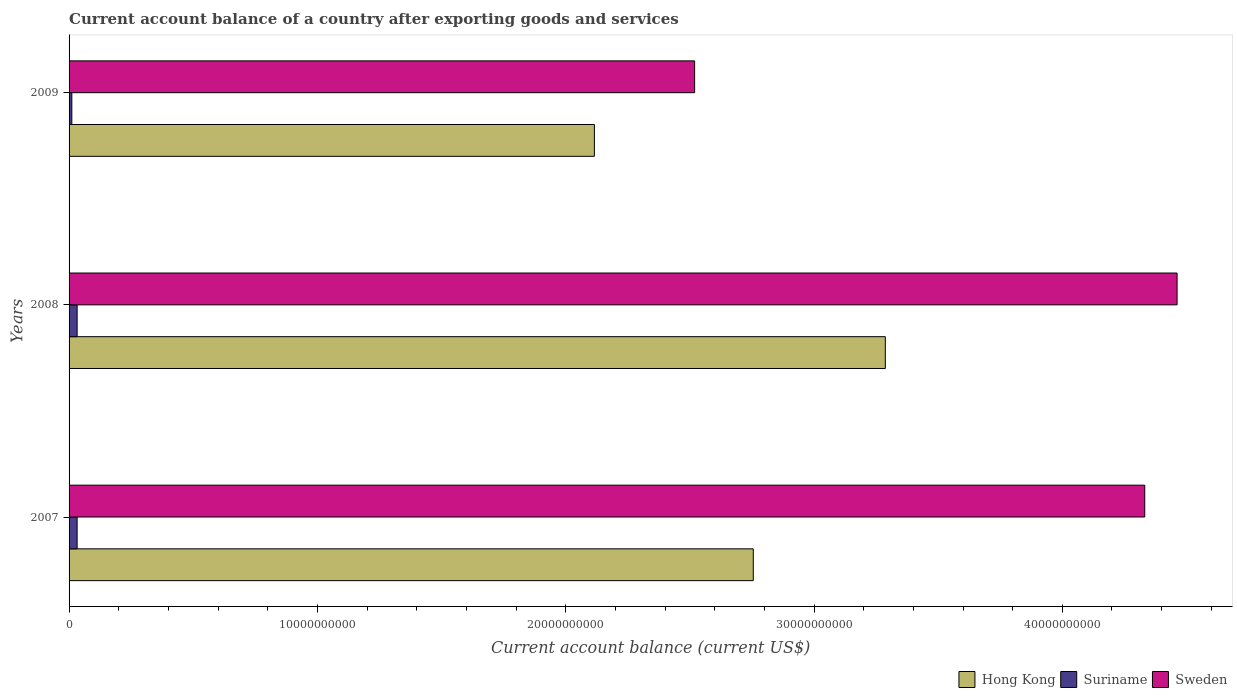How many different coloured bars are there?
Keep it short and to the point. 3. How many groups of bars are there?
Offer a terse response. 3. How many bars are there on the 1st tick from the top?
Provide a succinct answer. 3. What is the label of the 2nd group of bars from the top?
Offer a terse response. 2008. What is the account balance in Suriname in 2008?
Make the answer very short. 3.25e+08. Across all years, what is the maximum account balance in Hong Kong?
Offer a very short reply. 3.29e+1. Across all years, what is the minimum account balance in Suriname?
Give a very brief answer. 1.11e+08. In which year was the account balance in Hong Kong maximum?
Provide a succinct answer. 2008. What is the total account balance in Suriname in the graph?
Keep it short and to the point. 7.60e+08. What is the difference between the account balance in Sweden in 2007 and that in 2008?
Make the answer very short. -1.30e+09. What is the difference between the account balance in Suriname in 2009 and the account balance in Sweden in 2008?
Provide a short and direct response. -4.45e+1. What is the average account balance in Suriname per year?
Keep it short and to the point. 2.54e+08. In the year 2009, what is the difference between the account balance in Sweden and account balance in Suriname?
Offer a very short reply. 2.51e+1. What is the ratio of the account balance in Sweden in 2007 to that in 2008?
Offer a terse response. 0.97. Is the account balance in Suriname in 2008 less than that in 2009?
Offer a terse response. No. Is the difference between the account balance in Sweden in 2007 and 2009 greater than the difference between the account balance in Suriname in 2007 and 2009?
Your response must be concise. Yes. What is the difference between the highest and the second highest account balance in Hong Kong?
Your answer should be very brief. 5.32e+09. What is the difference between the highest and the lowest account balance in Sweden?
Offer a very short reply. 1.94e+1. In how many years, is the account balance in Hong Kong greater than the average account balance in Hong Kong taken over all years?
Provide a short and direct response. 2. Is the sum of the account balance in Sweden in 2008 and 2009 greater than the maximum account balance in Hong Kong across all years?
Your answer should be compact. Yes. What does the 2nd bar from the bottom in 2007 represents?
Your answer should be compact. Suriname. Are all the bars in the graph horizontal?
Your answer should be compact. Yes. Are the values on the major ticks of X-axis written in scientific E-notation?
Make the answer very short. No. Does the graph contain any zero values?
Offer a very short reply. No. Does the graph contain grids?
Ensure brevity in your answer.  No. Where does the legend appear in the graph?
Provide a succinct answer. Bottom right. What is the title of the graph?
Offer a very short reply. Current account balance of a country after exporting goods and services. Does "India" appear as one of the legend labels in the graph?
Keep it short and to the point. No. What is the label or title of the X-axis?
Ensure brevity in your answer.  Current account balance (current US$). What is the label or title of the Y-axis?
Provide a succinct answer. Years. What is the Current account balance (current US$) in Hong Kong in 2007?
Keep it short and to the point. 2.76e+1. What is the Current account balance (current US$) of Suriname in 2007?
Your answer should be very brief. 3.24e+08. What is the Current account balance (current US$) of Sweden in 2007?
Offer a terse response. 4.33e+1. What is the Current account balance (current US$) of Hong Kong in 2008?
Make the answer very short. 3.29e+1. What is the Current account balance (current US$) in Suriname in 2008?
Give a very brief answer. 3.25e+08. What is the Current account balance (current US$) of Sweden in 2008?
Keep it short and to the point. 4.46e+1. What is the Current account balance (current US$) in Hong Kong in 2009?
Ensure brevity in your answer.  2.12e+1. What is the Current account balance (current US$) of Suriname in 2009?
Keep it short and to the point. 1.11e+08. What is the Current account balance (current US$) in Sweden in 2009?
Your answer should be compact. 2.52e+1. Across all years, what is the maximum Current account balance (current US$) in Hong Kong?
Your answer should be compact. 3.29e+1. Across all years, what is the maximum Current account balance (current US$) of Suriname?
Provide a short and direct response. 3.25e+08. Across all years, what is the maximum Current account balance (current US$) in Sweden?
Give a very brief answer. 4.46e+1. Across all years, what is the minimum Current account balance (current US$) in Hong Kong?
Make the answer very short. 2.12e+1. Across all years, what is the minimum Current account balance (current US$) of Suriname?
Your answer should be compact. 1.11e+08. Across all years, what is the minimum Current account balance (current US$) of Sweden?
Offer a terse response. 2.52e+1. What is the total Current account balance (current US$) of Hong Kong in the graph?
Make the answer very short. 8.16e+1. What is the total Current account balance (current US$) of Suriname in the graph?
Provide a short and direct response. 7.60e+08. What is the total Current account balance (current US$) of Sweden in the graph?
Provide a succinct answer. 1.13e+11. What is the difference between the Current account balance (current US$) in Hong Kong in 2007 and that in 2008?
Keep it short and to the point. -5.32e+09. What is the difference between the Current account balance (current US$) in Suriname in 2007 and that in 2008?
Provide a short and direct response. -2.00e+05. What is the difference between the Current account balance (current US$) in Sweden in 2007 and that in 2008?
Provide a succinct answer. -1.30e+09. What is the difference between the Current account balance (current US$) of Hong Kong in 2007 and that in 2009?
Offer a terse response. 6.40e+09. What is the difference between the Current account balance (current US$) of Suriname in 2007 and that in 2009?
Your answer should be very brief. 2.13e+08. What is the difference between the Current account balance (current US$) in Sweden in 2007 and that in 2009?
Offer a very short reply. 1.81e+1. What is the difference between the Current account balance (current US$) of Hong Kong in 2008 and that in 2009?
Provide a short and direct response. 1.17e+1. What is the difference between the Current account balance (current US$) of Suriname in 2008 and that in 2009?
Keep it short and to the point. 2.13e+08. What is the difference between the Current account balance (current US$) of Sweden in 2008 and that in 2009?
Your response must be concise. 1.94e+1. What is the difference between the Current account balance (current US$) in Hong Kong in 2007 and the Current account balance (current US$) in Suriname in 2008?
Ensure brevity in your answer.  2.72e+1. What is the difference between the Current account balance (current US$) of Hong Kong in 2007 and the Current account balance (current US$) of Sweden in 2008?
Your response must be concise. -1.71e+1. What is the difference between the Current account balance (current US$) in Suriname in 2007 and the Current account balance (current US$) in Sweden in 2008?
Make the answer very short. -4.43e+1. What is the difference between the Current account balance (current US$) of Hong Kong in 2007 and the Current account balance (current US$) of Suriname in 2009?
Give a very brief answer. 2.74e+1. What is the difference between the Current account balance (current US$) of Hong Kong in 2007 and the Current account balance (current US$) of Sweden in 2009?
Give a very brief answer. 2.36e+09. What is the difference between the Current account balance (current US$) of Suriname in 2007 and the Current account balance (current US$) of Sweden in 2009?
Provide a succinct answer. -2.49e+1. What is the difference between the Current account balance (current US$) in Hong Kong in 2008 and the Current account balance (current US$) in Suriname in 2009?
Give a very brief answer. 3.28e+1. What is the difference between the Current account balance (current US$) in Hong Kong in 2008 and the Current account balance (current US$) in Sweden in 2009?
Give a very brief answer. 7.68e+09. What is the difference between the Current account balance (current US$) of Suriname in 2008 and the Current account balance (current US$) of Sweden in 2009?
Give a very brief answer. -2.49e+1. What is the average Current account balance (current US$) in Hong Kong per year?
Offer a terse response. 2.72e+1. What is the average Current account balance (current US$) in Suriname per year?
Ensure brevity in your answer.  2.54e+08. What is the average Current account balance (current US$) in Sweden per year?
Provide a succinct answer. 3.77e+1. In the year 2007, what is the difference between the Current account balance (current US$) in Hong Kong and Current account balance (current US$) in Suriname?
Give a very brief answer. 2.72e+1. In the year 2007, what is the difference between the Current account balance (current US$) in Hong Kong and Current account balance (current US$) in Sweden?
Ensure brevity in your answer.  -1.58e+1. In the year 2007, what is the difference between the Current account balance (current US$) in Suriname and Current account balance (current US$) in Sweden?
Offer a terse response. -4.30e+1. In the year 2008, what is the difference between the Current account balance (current US$) of Hong Kong and Current account balance (current US$) of Suriname?
Offer a terse response. 3.25e+1. In the year 2008, what is the difference between the Current account balance (current US$) of Hong Kong and Current account balance (current US$) of Sweden?
Provide a succinct answer. -1.17e+1. In the year 2008, what is the difference between the Current account balance (current US$) in Suriname and Current account balance (current US$) in Sweden?
Your response must be concise. -4.43e+1. In the year 2009, what is the difference between the Current account balance (current US$) in Hong Kong and Current account balance (current US$) in Suriname?
Provide a short and direct response. 2.10e+1. In the year 2009, what is the difference between the Current account balance (current US$) in Hong Kong and Current account balance (current US$) in Sweden?
Make the answer very short. -4.04e+09. In the year 2009, what is the difference between the Current account balance (current US$) in Suriname and Current account balance (current US$) in Sweden?
Make the answer very short. -2.51e+1. What is the ratio of the Current account balance (current US$) in Hong Kong in 2007 to that in 2008?
Your answer should be compact. 0.84. What is the ratio of the Current account balance (current US$) in Suriname in 2007 to that in 2008?
Give a very brief answer. 1. What is the ratio of the Current account balance (current US$) of Sweden in 2007 to that in 2008?
Provide a succinct answer. 0.97. What is the ratio of the Current account balance (current US$) in Hong Kong in 2007 to that in 2009?
Give a very brief answer. 1.3. What is the ratio of the Current account balance (current US$) of Suriname in 2007 to that in 2009?
Keep it short and to the point. 2.92. What is the ratio of the Current account balance (current US$) of Sweden in 2007 to that in 2009?
Provide a succinct answer. 1.72. What is the ratio of the Current account balance (current US$) of Hong Kong in 2008 to that in 2009?
Your answer should be very brief. 1.55. What is the ratio of the Current account balance (current US$) in Suriname in 2008 to that in 2009?
Make the answer very short. 2.92. What is the ratio of the Current account balance (current US$) in Sweden in 2008 to that in 2009?
Make the answer very short. 1.77. What is the difference between the highest and the second highest Current account balance (current US$) of Hong Kong?
Your answer should be very brief. 5.32e+09. What is the difference between the highest and the second highest Current account balance (current US$) of Suriname?
Keep it short and to the point. 2.00e+05. What is the difference between the highest and the second highest Current account balance (current US$) in Sweden?
Your answer should be compact. 1.30e+09. What is the difference between the highest and the lowest Current account balance (current US$) of Hong Kong?
Offer a very short reply. 1.17e+1. What is the difference between the highest and the lowest Current account balance (current US$) in Suriname?
Offer a very short reply. 2.13e+08. What is the difference between the highest and the lowest Current account balance (current US$) of Sweden?
Ensure brevity in your answer.  1.94e+1. 